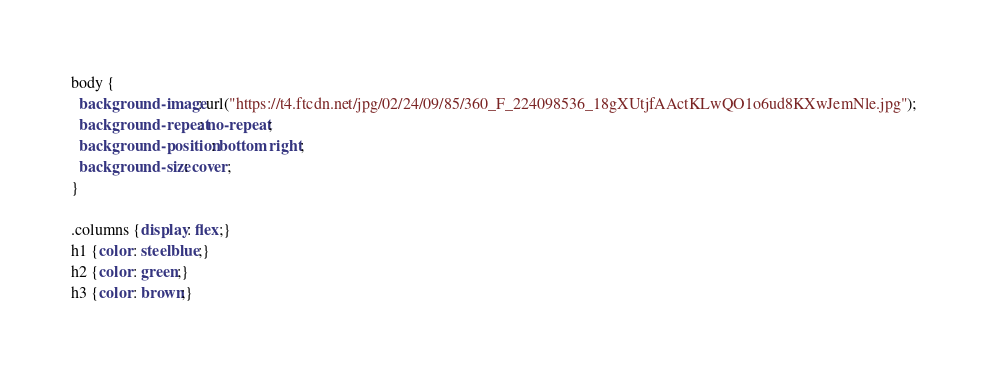Convert code to text. <code><loc_0><loc_0><loc_500><loc_500><_CSS_>body {
  background-image: url("https://t4.ftcdn.net/jpg/02/24/09/85/360_F_224098536_18gXUtjfAActKLwQO1o6ud8KXwJemNle.jpg");
  background-repeat: no-repeat;
  background-position: bottom right;
  background-size: cover;
}

.columns {display: flex;}
h1 {color: steelblue;}
h2 {color: green;}
h3 {color: brown;}</code> 